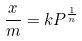<formula> <loc_0><loc_0><loc_500><loc_500>\frac { x } { m } = k P ^ { \frac { 1 } { n } }</formula> 